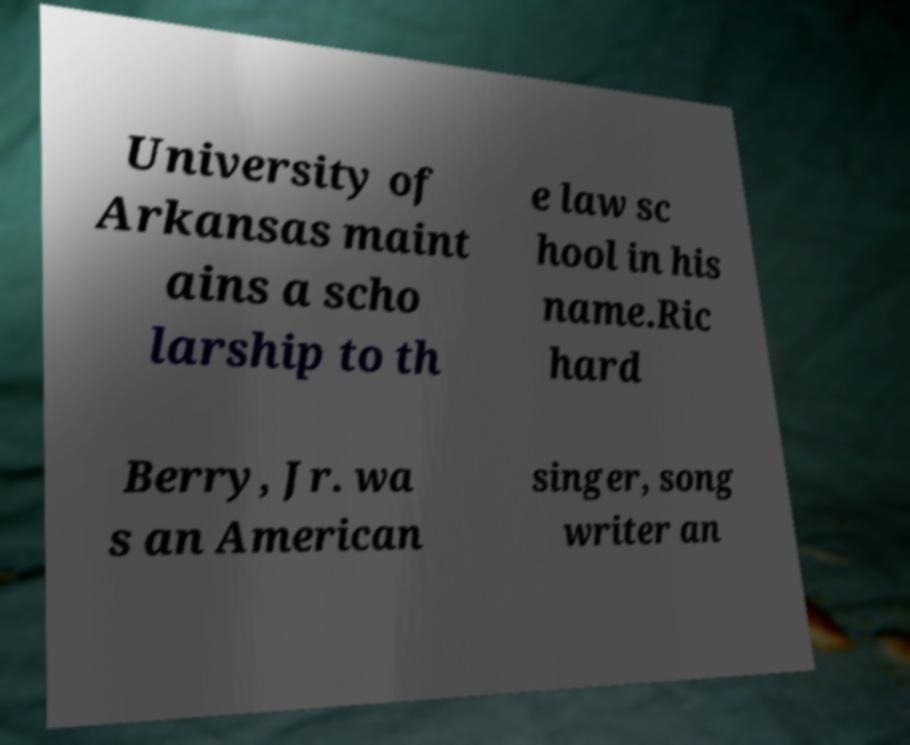Could you extract and type out the text from this image? University of Arkansas maint ains a scho larship to th e law sc hool in his name.Ric hard Berry, Jr. wa s an American singer, song writer an 